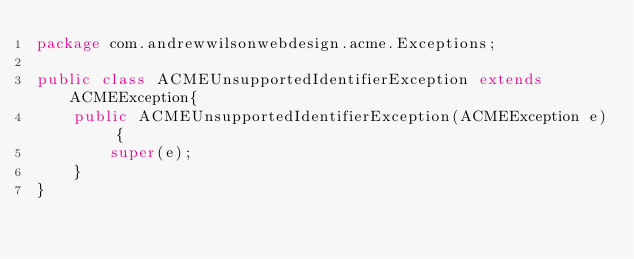<code> <loc_0><loc_0><loc_500><loc_500><_Java_>package com.andrewwilsonwebdesign.acme.Exceptions;

public class ACMEUnsupportedIdentifierException extends ACMEException{
    public ACMEUnsupportedIdentifierException(ACMEException e) {
        super(e);
    }
}
</code> 